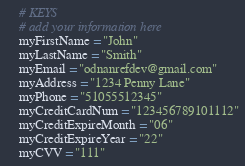<code> <loc_0><loc_0><loc_500><loc_500><_Python_>
    # KEYS
    # add your information here
    myFirstName = "John"
    myLastName = "Smith"
    myEmail = "odnanrefdev@gmail.com"
    myAddress = "1234 Penny Lane"
    myPhone = "51055512345"
    myCreditCardNum = "123456789101112"
    myCreditExpireMonth = "06"
    myCreditExpireYear = "22"
    myCVV = "111"
</code> 